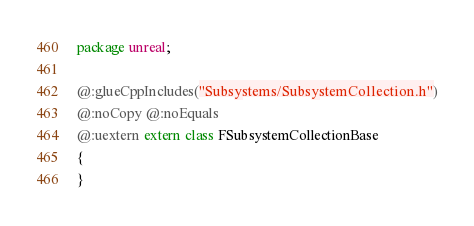<code> <loc_0><loc_0><loc_500><loc_500><_Haxe_>package unreal;

@:glueCppIncludes("Subsystems/SubsystemCollection.h")
@:noCopy @:noEquals
@:uextern extern class FSubsystemCollectionBase
{
}</code> 